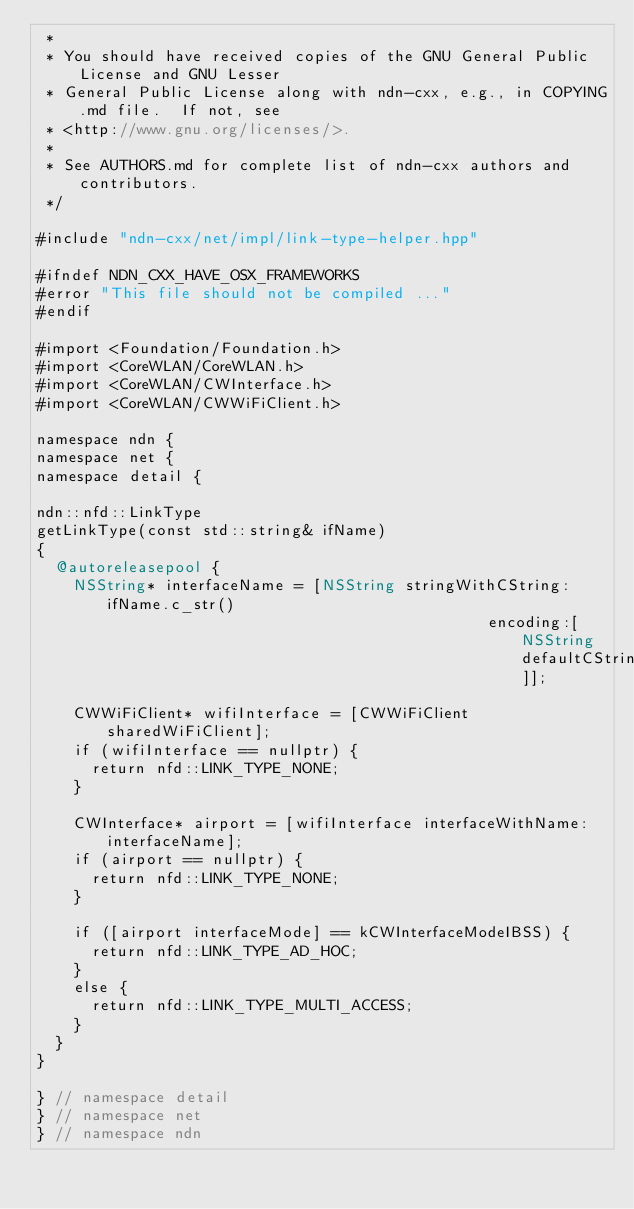Convert code to text. <code><loc_0><loc_0><loc_500><loc_500><_ObjectiveC_> *
 * You should have received copies of the GNU General Public License and GNU Lesser
 * General Public License along with ndn-cxx, e.g., in COPYING.md file.  If not, see
 * <http://www.gnu.org/licenses/>.
 *
 * See AUTHORS.md for complete list of ndn-cxx authors and contributors.
 */

#include "ndn-cxx/net/impl/link-type-helper.hpp"

#ifndef NDN_CXX_HAVE_OSX_FRAMEWORKS
#error "This file should not be compiled ..."
#endif

#import <Foundation/Foundation.h>
#import <CoreWLAN/CoreWLAN.h>
#import <CoreWLAN/CWInterface.h>
#import <CoreWLAN/CWWiFiClient.h>

namespace ndn {
namespace net {
namespace detail {

ndn::nfd::LinkType
getLinkType(const std::string& ifName)
{
  @autoreleasepool {
    NSString* interfaceName = [NSString stringWithCString:ifName.c_str()
                                                 encoding:[NSString defaultCStringEncoding]];

    CWWiFiClient* wifiInterface = [CWWiFiClient sharedWiFiClient];
    if (wifiInterface == nullptr) {
      return nfd::LINK_TYPE_NONE;
    }

    CWInterface* airport = [wifiInterface interfaceWithName:interfaceName];
    if (airport == nullptr) {
      return nfd::LINK_TYPE_NONE;
    }

    if ([airport interfaceMode] == kCWInterfaceModeIBSS) {
      return nfd::LINK_TYPE_AD_HOC;
    }
    else {
      return nfd::LINK_TYPE_MULTI_ACCESS;
    }
  }
}

} // namespace detail
} // namespace net
} // namespace ndn
</code> 